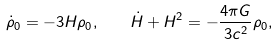<formula> <loc_0><loc_0><loc_500><loc_500>\dot { \rho } _ { 0 } = - 3 H \rho _ { 0 } , \quad \dot { H } + H ^ { 2 } = - \frac { 4 \pi G } { 3 c ^ { 2 } } \rho _ { 0 } ,</formula> 